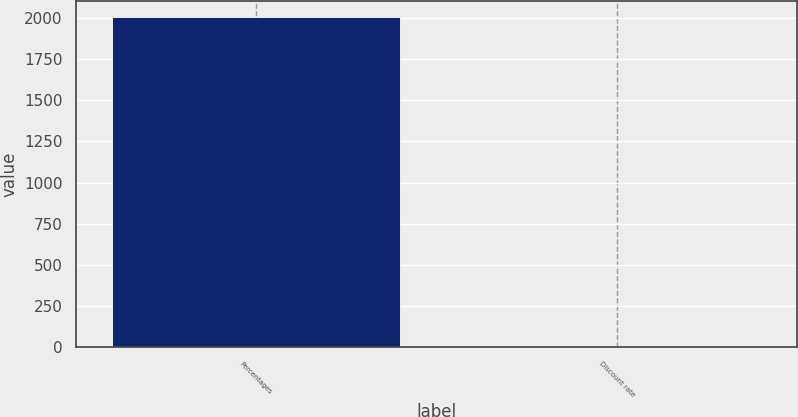<chart> <loc_0><loc_0><loc_500><loc_500><bar_chart><fcel>Percentages<fcel>Discount rate<nl><fcel>2005<fcel>6<nl></chart> 